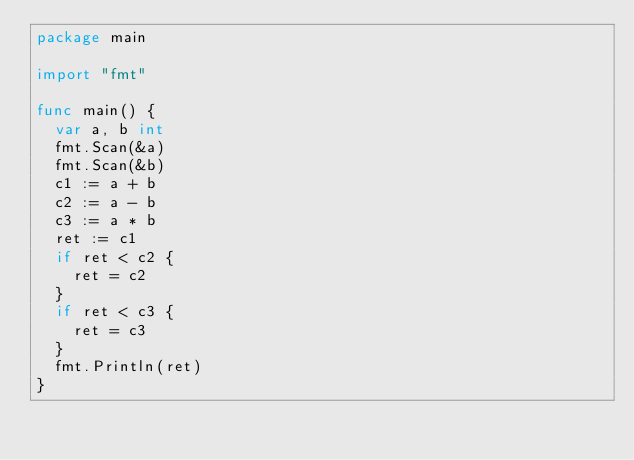<code> <loc_0><loc_0><loc_500><loc_500><_Go_>package main

import "fmt"

func main() {
	var a, b int
	fmt.Scan(&a)
	fmt.Scan(&b)
	c1 := a + b
	c2 := a - b
	c3 := a * b
	ret := c1
	if ret < c2 {
		ret = c2
	}
	if ret < c3 {
		ret = c3
	}
	fmt.Println(ret)
}
</code> 